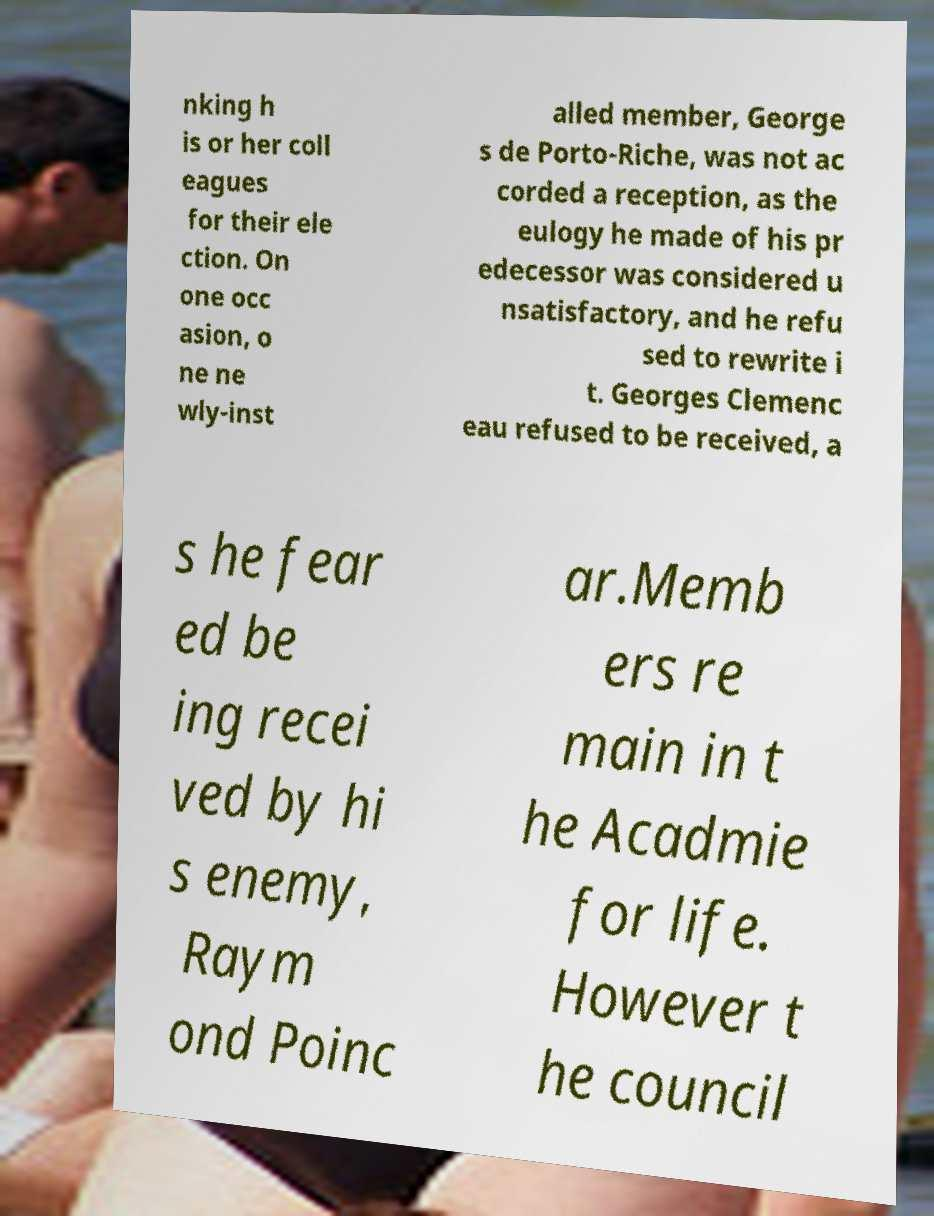Could you extract and type out the text from this image? nking h is or her coll eagues for their ele ction. On one occ asion, o ne ne wly-inst alled member, George s de Porto-Riche, was not ac corded a reception, as the eulogy he made of his pr edecessor was considered u nsatisfactory, and he refu sed to rewrite i t. Georges Clemenc eau refused to be received, a s he fear ed be ing recei ved by hi s enemy, Raym ond Poinc ar.Memb ers re main in t he Acadmie for life. However t he council 